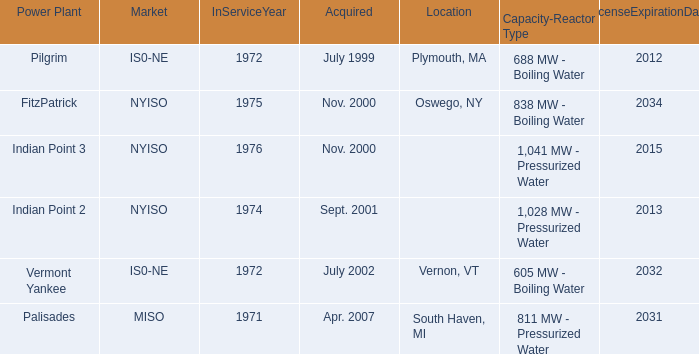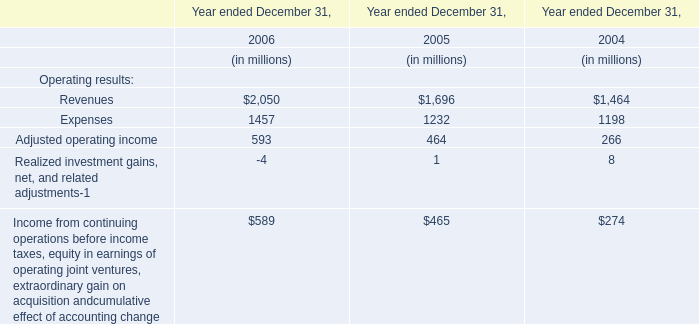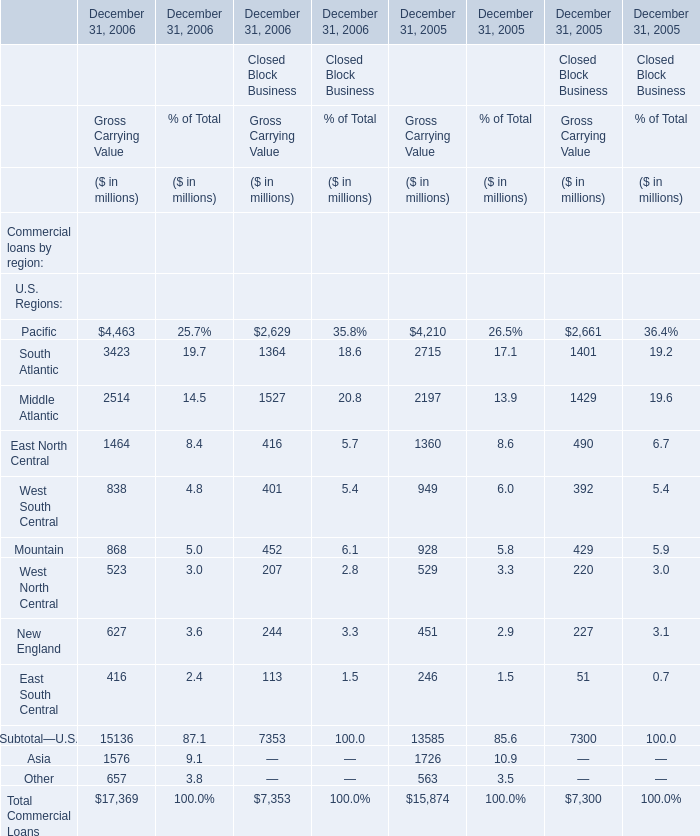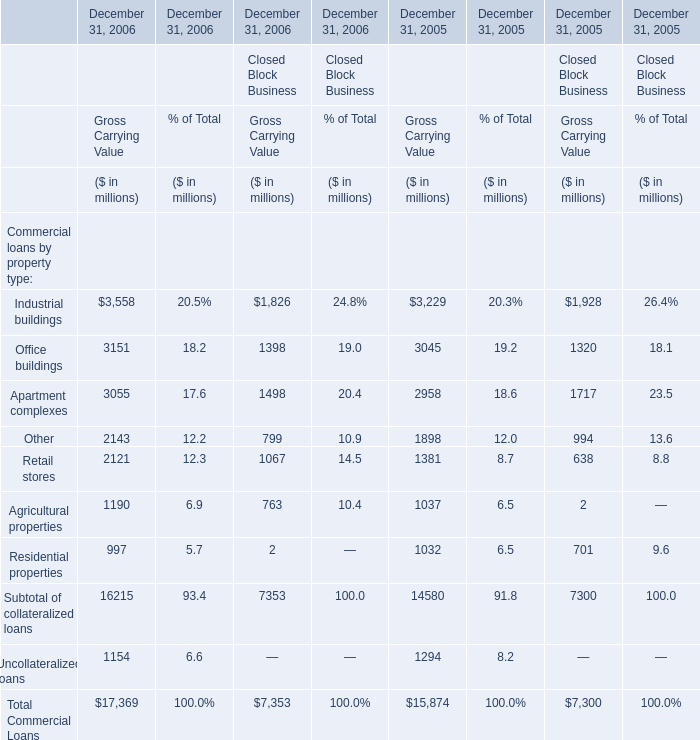What was the total amount of South Atlantic in 2006 for Gross Carrying Value? (in million) 
Computations: (3423 + 1364)
Answer: 4787.0. 